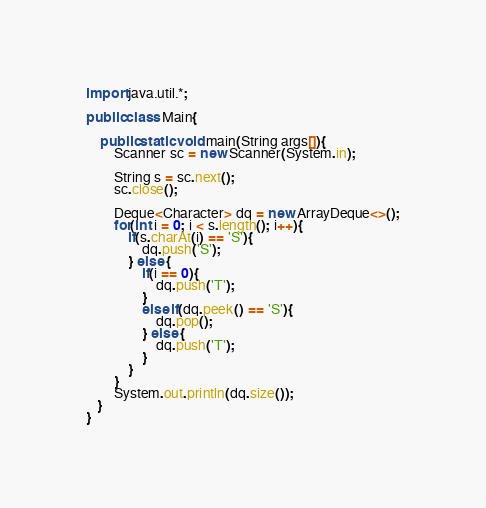Convert code to text. <code><loc_0><loc_0><loc_500><loc_500><_Java_>import java.util.*;

public class Main{
    
    public static void main(String args[]){
        Scanner sc = new Scanner(System.in);
        
        String s = sc.next();
        sc.close();

        Deque<Character> dq = new ArrayDeque<>();
        for(int i = 0; i < s.length(); i++){
            if(s.charAt(i) == 'S'){
                dq.push('S');
            } else {
                if(i == 0){
                    dq.push('T');
                }
                else if(dq.peek() == 'S'){
                    dq.pop();
                } else {
                    dq.push('T');
                }
            }
        }
        System.out.println(dq.size());
   }
}</code> 